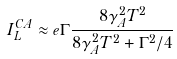<formula> <loc_0><loc_0><loc_500><loc_500>I _ { L } ^ { C A } \approx e \Gamma \frac { 8 \gamma _ { A } ^ { 2 } T ^ { 2 } } { 8 \gamma _ { A } ^ { 2 } T ^ { 2 } + \Gamma ^ { 2 } / 4 }</formula> 